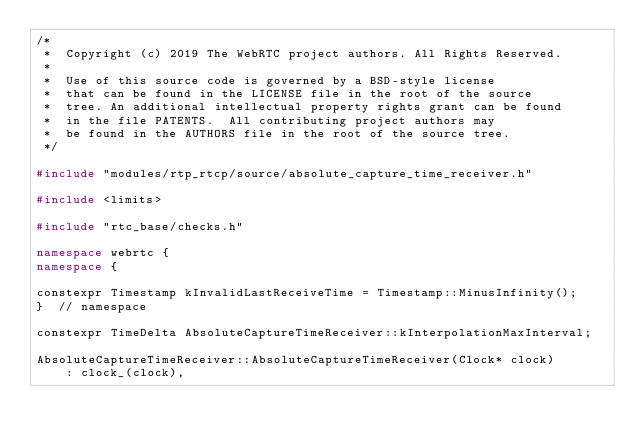Convert code to text. <code><loc_0><loc_0><loc_500><loc_500><_C++_>/*
 *  Copyright (c) 2019 The WebRTC project authors. All Rights Reserved.
 *
 *  Use of this source code is governed by a BSD-style license
 *  that can be found in the LICENSE file in the root of the source
 *  tree. An additional intellectual property rights grant can be found
 *  in the file PATENTS.  All contributing project authors may
 *  be found in the AUTHORS file in the root of the source tree.
 */

#include "modules/rtp_rtcp/source/absolute_capture_time_receiver.h"

#include <limits>

#include "rtc_base/checks.h"

namespace webrtc {
namespace {

constexpr Timestamp kInvalidLastReceiveTime = Timestamp::MinusInfinity();
}  // namespace

constexpr TimeDelta AbsoluteCaptureTimeReceiver::kInterpolationMaxInterval;

AbsoluteCaptureTimeReceiver::AbsoluteCaptureTimeReceiver(Clock* clock)
    : clock_(clock),</code> 